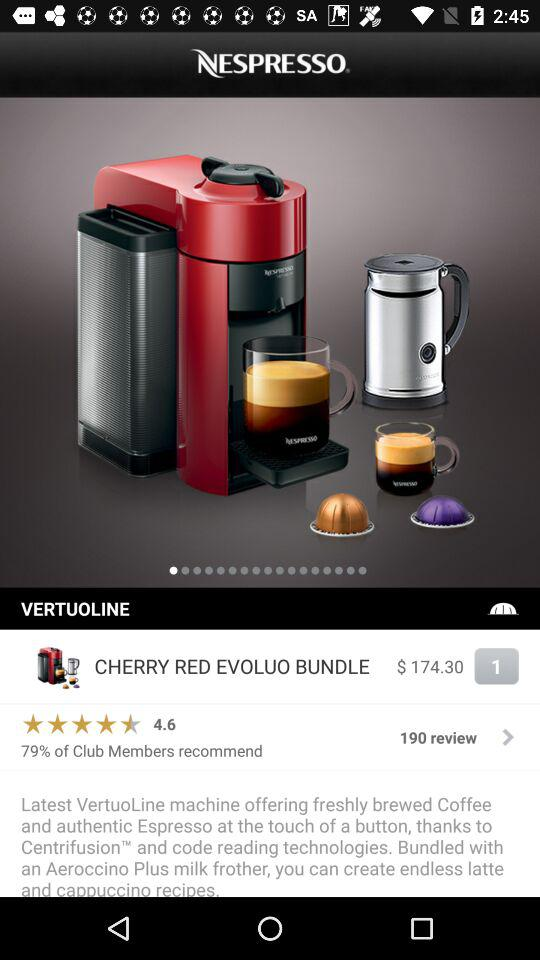How many people gave reviews? The number of people who gave reviews is 190. 